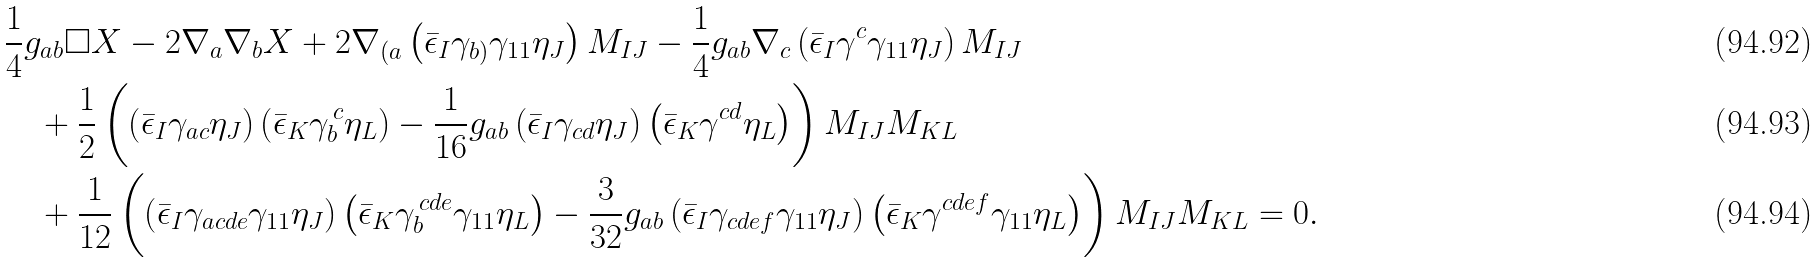<formula> <loc_0><loc_0><loc_500><loc_500>& \frac { 1 } { 4 } g _ { a b } \Box X - 2 \nabla _ { a } \nabla _ { b } X + 2 \nabla _ { ( a } \left ( \bar { \epsilon } _ { I } \gamma _ { b ) } \gamma _ { 1 1 } \eta _ { J } \right ) M _ { I J } - \frac { 1 } { 4 } g _ { a b } \nabla _ { c } \left ( \bar { \epsilon } _ { I } \gamma ^ { c } \gamma _ { 1 1 } \eta _ { J } \right ) M _ { I J } \\ & \quad + \frac { 1 } { 2 } \left ( \left ( \bar { \epsilon } _ { I } \gamma _ { a c } \eta _ { J } \right ) \left ( \bar { \epsilon } _ { K } \gamma _ { b } ^ { \, c } \eta _ { L } \right ) - \frac { 1 } { 1 6 } g _ { a b } \left ( \bar { \epsilon } _ { I } \gamma _ { c d } \eta _ { J } \right ) \left ( \bar { \epsilon } _ { K } \gamma ^ { c d } \eta _ { L } \right ) \right ) M _ { I J } M _ { K L } \\ & \quad + \frac { 1 } { 1 2 } \left ( \left ( \bar { \epsilon } _ { I } \gamma _ { a c d e } \gamma _ { 1 1 } \eta _ { J } \right ) \left ( \bar { \epsilon } _ { K } \gamma _ { b } ^ { \, c d e } \gamma _ { 1 1 } \eta _ { L } \right ) - \frac { 3 } { 3 2 } g _ { a b } \left ( \bar { \epsilon } _ { I } \gamma _ { c d e f } \gamma _ { 1 1 } \eta _ { J } \right ) \left ( \bar { \epsilon } _ { K } \gamma ^ { c d e f } \gamma _ { 1 1 } \eta _ { L } \right ) \right ) M _ { I J } M _ { K L } = 0 .</formula> 